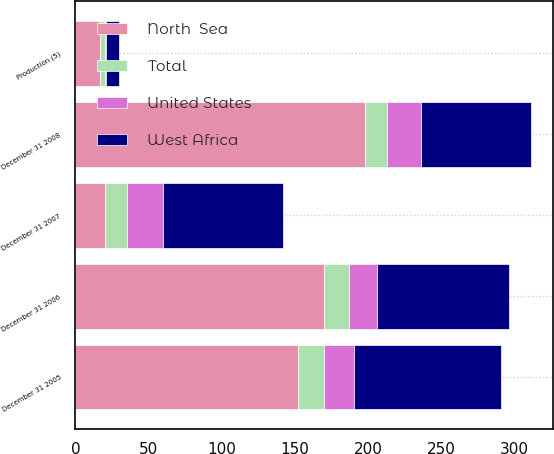Convert chart. <chart><loc_0><loc_0><loc_500><loc_500><stacked_bar_chart><ecel><fcel>December 31 2005<fcel>Production (5)<fcel>December 31 2006<fcel>December 31 2007<fcel>December 31 2008<nl><fcel>North  Sea<fcel>152<fcel>17<fcel>170<fcel>20<fcel>198<nl><fcel>West Africa<fcel>101<fcel>9<fcel>90<fcel>82<fcel>75<nl><fcel>United States<fcel>20<fcel>1<fcel>19<fcel>25<fcel>23<nl><fcel>Total<fcel>18<fcel>3<fcel>17<fcel>15<fcel>15<nl></chart> 